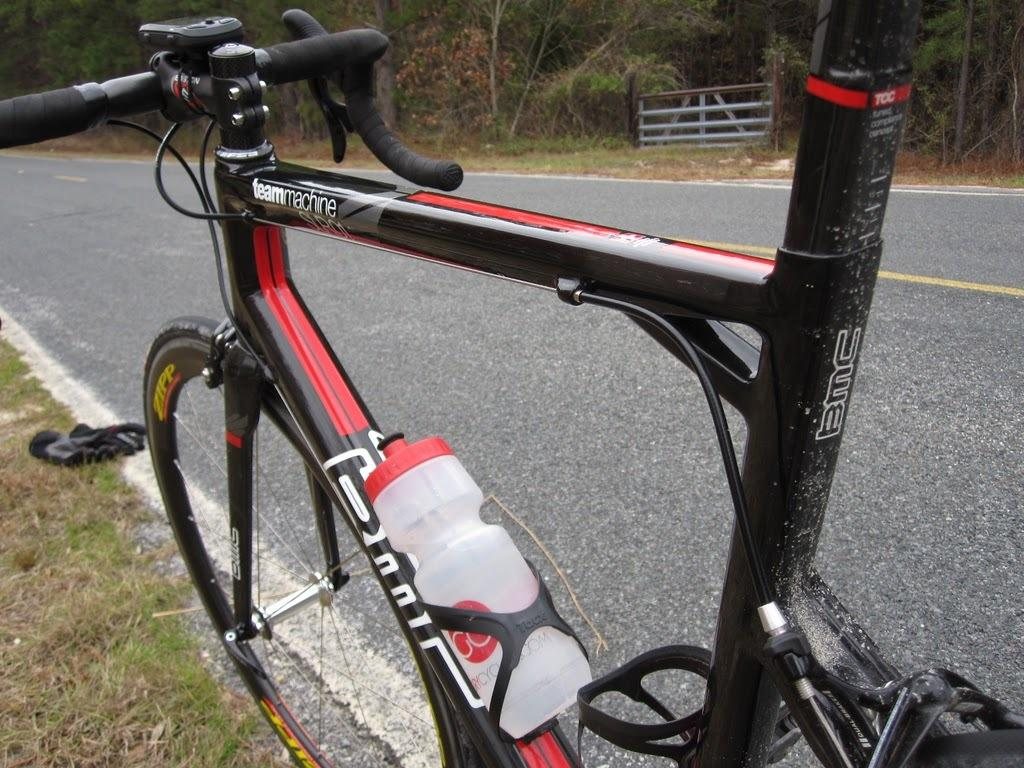What is the main object in the image? There is a cycle in the image. Where is the cycle located? The cycle is parked beside a road. What can be seen around the road in the image? There are many trees around the road. What type of vegetation is visible in the image? There is grass visible in the image. What type of alarm can be heard going off in the image? There is no alarm present or audible in the image. What flavor of mint is growing in the grass in the image? There is no mint plant visible in the image. 